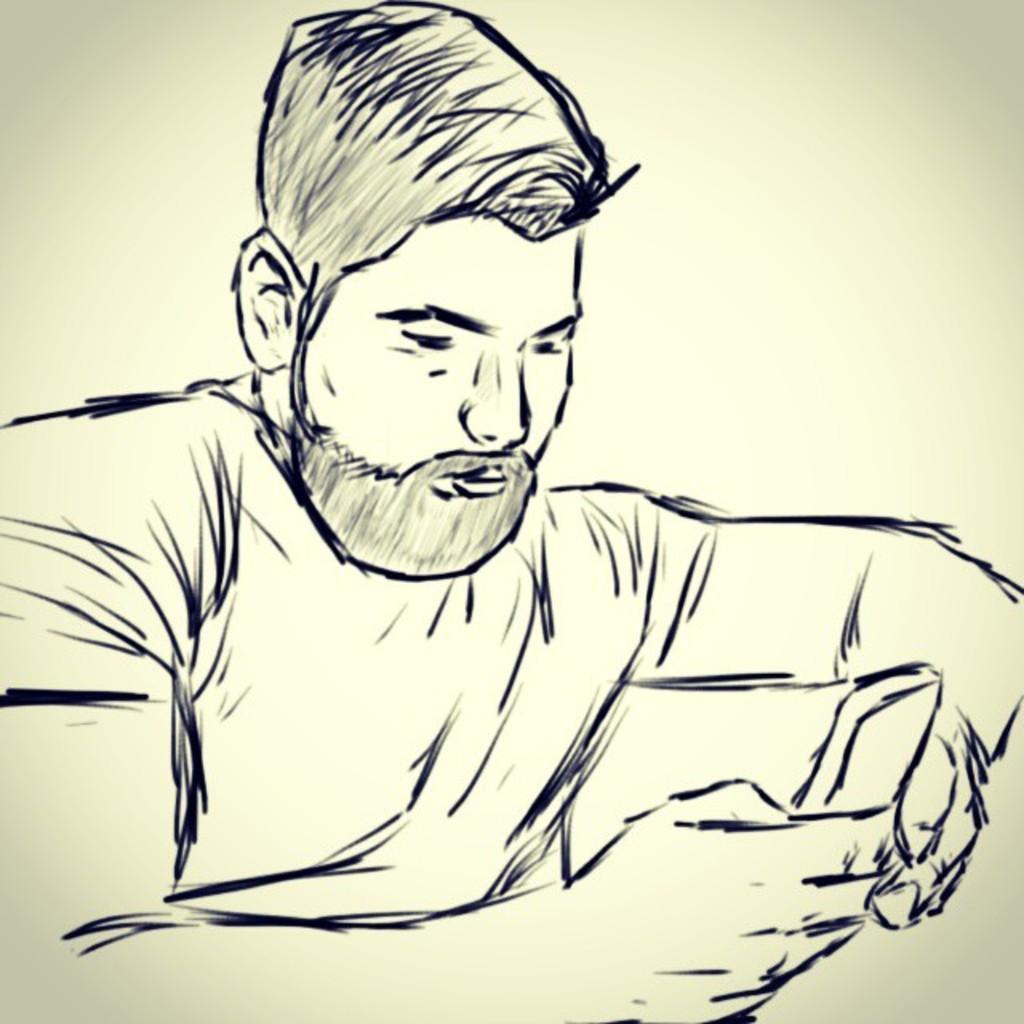How would you summarize this image in a sentence or two? In this image I can see the art of the person and I can see the cream color background. 